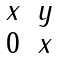Convert formula to latex. <formula><loc_0><loc_0><loc_500><loc_500>\begin{matrix} x & y \\ 0 & x \end{matrix}</formula> 